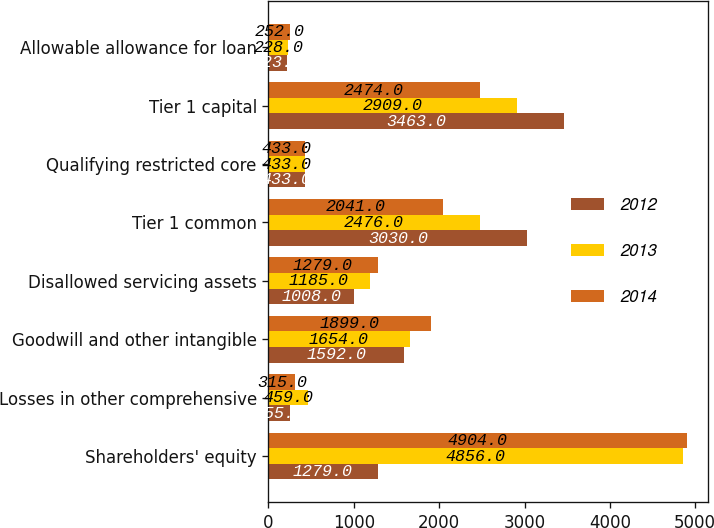<chart> <loc_0><loc_0><loc_500><loc_500><stacked_bar_chart><ecel><fcel>Shareholders' equity<fcel>Losses in other comprehensive<fcel>Goodwill and other intangible<fcel>Disallowed servicing assets<fcel>Tier 1 common<fcel>Qualifying restricted core<fcel>Tier 1 capital<fcel>Allowable allowance for loan<nl><fcel>2012<fcel>1279<fcel>255<fcel>1592<fcel>1008<fcel>3030<fcel>433<fcel>3463<fcel>223<nl><fcel>2013<fcel>4856<fcel>459<fcel>1654<fcel>1185<fcel>2476<fcel>433<fcel>2909<fcel>228<nl><fcel>2014<fcel>4904<fcel>315<fcel>1899<fcel>1279<fcel>2041<fcel>433<fcel>2474<fcel>252<nl></chart> 